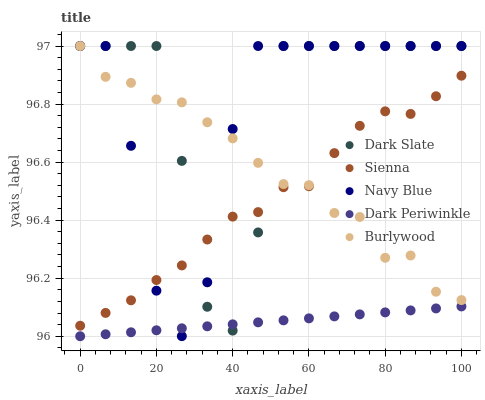Does Dark Periwinkle have the minimum area under the curve?
Answer yes or no. Yes. Does Dark Slate have the maximum area under the curve?
Answer yes or no. Yes. Does Dark Slate have the minimum area under the curve?
Answer yes or no. No. Does Dark Periwinkle have the maximum area under the curve?
Answer yes or no. No. Is Dark Periwinkle the smoothest?
Answer yes or no. Yes. Is Dark Slate the roughest?
Answer yes or no. Yes. Is Dark Slate the smoothest?
Answer yes or no. No. Is Dark Periwinkle the roughest?
Answer yes or no. No. Does Dark Periwinkle have the lowest value?
Answer yes or no. Yes. Does Dark Slate have the lowest value?
Answer yes or no. No. Does Navy Blue have the highest value?
Answer yes or no. Yes. Does Dark Periwinkle have the highest value?
Answer yes or no. No. Is Dark Periwinkle less than Sienna?
Answer yes or no. Yes. Is Burlywood greater than Dark Periwinkle?
Answer yes or no. Yes. Does Sienna intersect Dark Slate?
Answer yes or no. Yes. Is Sienna less than Dark Slate?
Answer yes or no. No. Is Sienna greater than Dark Slate?
Answer yes or no. No. Does Dark Periwinkle intersect Sienna?
Answer yes or no. No. 